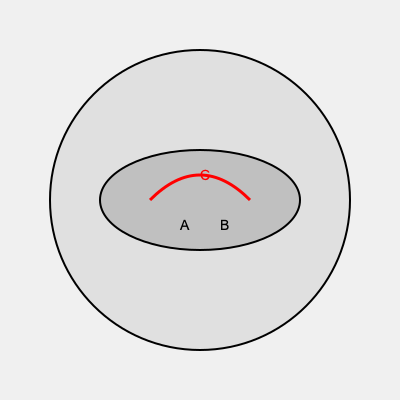In this 3D MRI scan of a brain, identify the structure labeled 'C' (highlighted in red). To interpret this 3D medical imaging scan and identify the structure labeled 'C', follow these steps:

1. Orientation: The image shows a cross-sectional view of a brain, with the front of the brain facing upwards.

2. Anatomical structures:
   a) The large circular outline represents the entire brain.
   b) The elliptical shape in the center represents the ventricles.
   c) The curved red line labeled 'C' is positioned above the ventricles.

3. Location and shape: The structure 'C' is a curved line connecting the left and right hemispheres of the brain, positioned superior to the ventricles.

4. Anatomical knowledge: Based on its location and shape, the structure labeled 'C' is consistent with the corpus callosum, a large bundle of nerve fibers that connects the two cerebral hemispheres.

5. Function: The corpus callosum is crucial for communication between the left and right sides of the brain, allowing for the integration of motor, sensory, and cognitive information.

Given these observations and anatomical considerations, the structure labeled 'C' can be identified as the corpus callosum.
Answer: Corpus callosum 